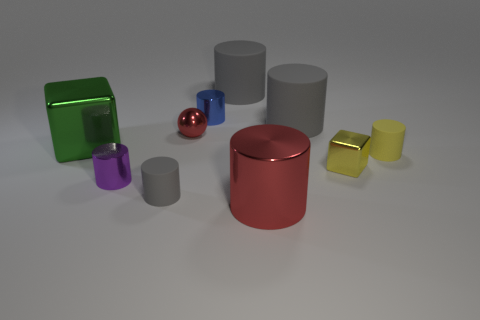Is there any other thing that has the same shape as the tiny red thing?
Your response must be concise. No. Is the green thing the same size as the red ball?
Provide a short and direct response. No. What is the material of the cube on the left side of the gray matte cylinder that is in front of the red metallic thing that is behind the yellow matte cylinder?
Provide a short and direct response. Metal. Is the number of small purple metal cylinders that are right of the green object the same as the number of tiny purple shiny objects?
Offer a very short reply. Yes. What number of things are either cyan metallic balls or matte objects?
Your answer should be compact. 4. There is a tiny blue object that is the same material as the green thing; what is its shape?
Your answer should be very brief. Cylinder. How big is the red metal thing in front of the gray rubber cylinder that is in front of the large green cube?
Make the answer very short. Large. How many large things are green blocks or gray objects?
Your response must be concise. 3. What number of other things are there of the same color as the tiny sphere?
Provide a succinct answer. 1. There is a metal cylinder that is behind the green thing; is its size the same as the gray object in front of the tiny yellow matte cylinder?
Provide a short and direct response. Yes. 